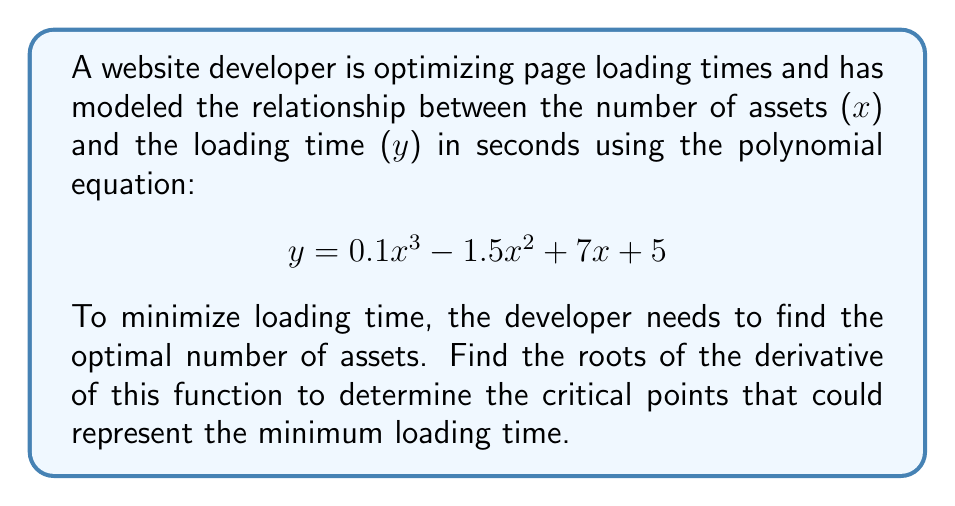What is the answer to this math problem? To find the optimal number of assets for minimum loading time, we need to follow these steps:

1) First, we need to find the derivative of the given function:
   $y = 0.1x^3 - 1.5x^2 + 7x + 5$
   $\frac{dy}{dx} = 0.3x^2 - 3x + 7$

2) To find the critical points, we set the derivative equal to zero:
   $0.3x^2 - 3x + 7 = 0$

3) This is a quadratic equation. We can solve it using the quadratic formula:
   $x = \frac{-b \pm \sqrt{b^2 - 4ac}}{2a}$

   Where $a = 0.3$, $b = -3$, and $c = 7$

4) Substituting these values:
   $x = \frac{3 \pm \sqrt{(-3)^2 - 4(0.3)(7)}}{2(0.3)}$
   $x = \frac{3 \pm \sqrt{9 - 8.4}}{0.6}$
   $x = \frac{3 \pm \sqrt{0.6}}{0.6}$
   $x = \frac{3 \pm 0.7746}{0.6}$

5) This gives us two solutions:
   $x_1 = \frac{3 + 0.7746}{0.6} \approx 6.29$
   $x_2 = \frac{3 - 0.7746}{0.6} \approx 3.71$

These are the critical points where the loading time could be at a minimum or maximum. To determine which one gives the minimum loading time, we'd need to evaluate the original function at these points and compare them.
Answer: The roots of the derivative are approximately 6.29 and 3.71, representing the critical points where the loading time could be minimized. 